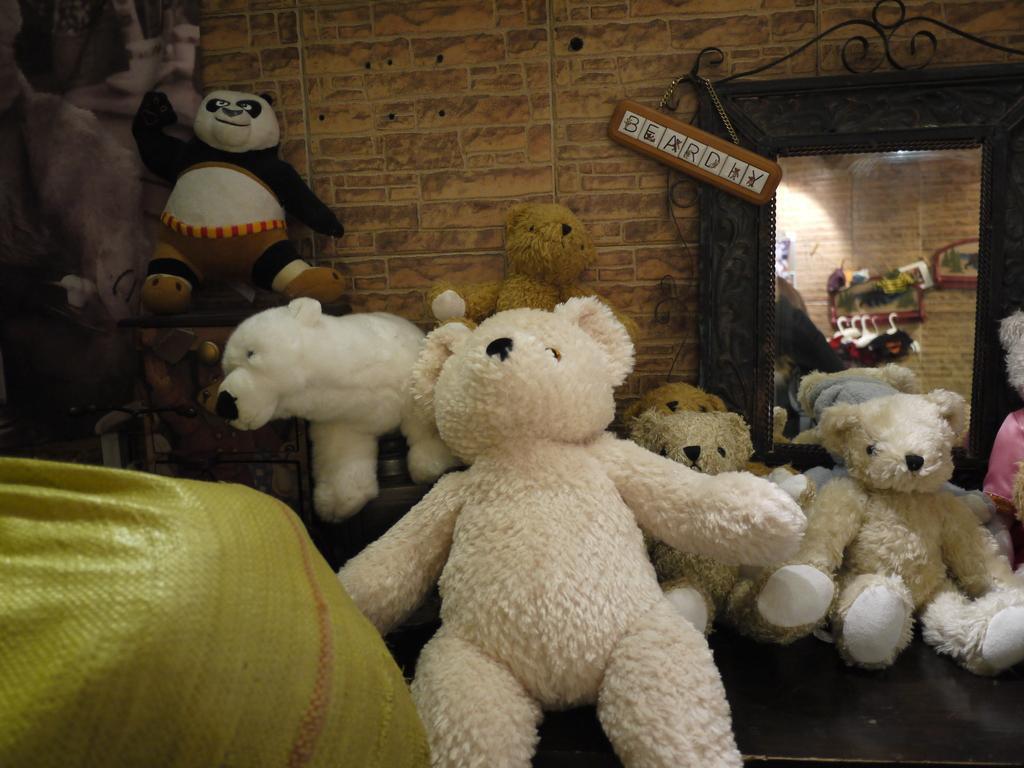Could you give a brief overview of what you see in this image? In this image, we can see so many soft toys. Left side bottom, we can see a yellow bag. Background there is a wall. Here we can see some board with chain. Right side of the image, we can see a mirror. Through the mirror, we can see some showpieces, brick wall. 